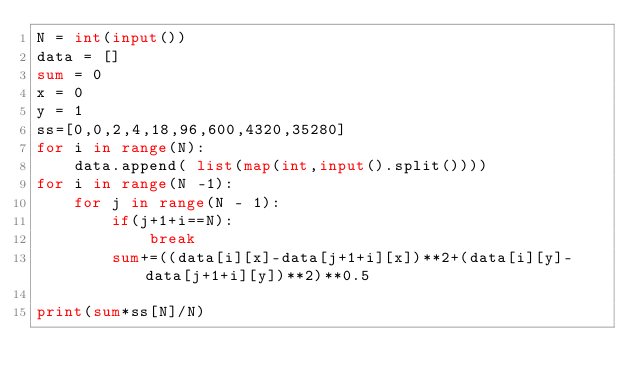<code> <loc_0><loc_0><loc_500><loc_500><_Python_>N = int(input())
data = []
sum = 0
x = 0
y = 1
ss=[0,0,2,4,18,96,600,4320,35280]
for i in range(N):
    data.append( list(map(int,input().split())))
for i in range(N -1):
    for j in range(N - 1):
        if(j+1+i==N):
            break
        sum+=((data[i][x]-data[j+1+i][x])**2+(data[i][y]-data[j+1+i][y])**2)**0.5

print(sum*ss[N]/N)
</code> 